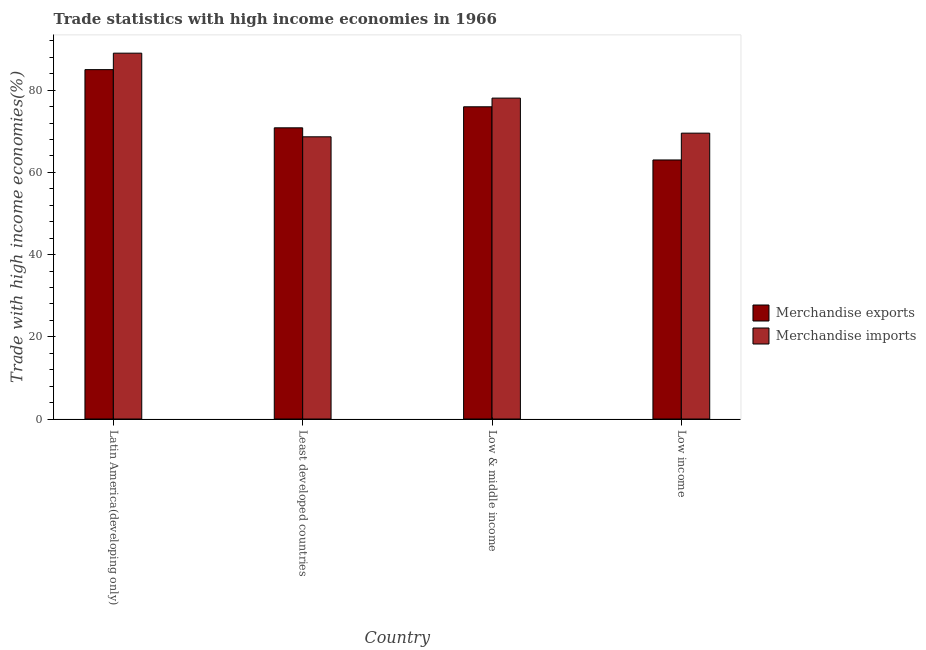How many groups of bars are there?
Your answer should be very brief. 4. What is the label of the 3rd group of bars from the left?
Make the answer very short. Low & middle income. What is the merchandise exports in Low income?
Make the answer very short. 63.03. Across all countries, what is the maximum merchandise exports?
Keep it short and to the point. 85.01. Across all countries, what is the minimum merchandise exports?
Your answer should be compact. 63.03. In which country was the merchandise imports maximum?
Make the answer very short. Latin America(developing only). What is the total merchandise imports in the graph?
Provide a succinct answer. 305.31. What is the difference between the merchandise imports in Latin America(developing only) and that in Low & middle income?
Provide a short and direct response. 10.93. What is the difference between the merchandise exports in Latin America(developing only) and the merchandise imports in Low & middle income?
Provide a short and direct response. 6.93. What is the average merchandise exports per country?
Your response must be concise. 73.71. What is the difference between the merchandise exports and merchandise imports in Least developed countries?
Provide a short and direct response. 2.19. What is the ratio of the merchandise exports in Least developed countries to that in Low & middle income?
Make the answer very short. 0.93. What is the difference between the highest and the second highest merchandise exports?
Offer a terse response. 9.04. What is the difference between the highest and the lowest merchandise imports?
Your answer should be compact. 20.35. In how many countries, is the merchandise imports greater than the average merchandise imports taken over all countries?
Your answer should be compact. 2. What does the 2nd bar from the left in Low & middle income represents?
Offer a very short reply. Merchandise imports. What is the difference between two consecutive major ticks on the Y-axis?
Provide a short and direct response. 20. Are the values on the major ticks of Y-axis written in scientific E-notation?
Your response must be concise. No. Does the graph contain grids?
Your answer should be compact. No. Where does the legend appear in the graph?
Provide a short and direct response. Center right. How are the legend labels stacked?
Keep it short and to the point. Vertical. What is the title of the graph?
Your response must be concise. Trade statistics with high income economies in 1966. Does "Overweight" appear as one of the legend labels in the graph?
Offer a very short reply. No. What is the label or title of the Y-axis?
Make the answer very short. Trade with high income economies(%). What is the Trade with high income economies(%) of Merchandise exports in Latin America(developing only)?
Keep it short and to the point. 85.01. What is the Trade with high income economies(%) in Merchandise imports in Latin America(developing only)?
Your response must be concise. 89.01. What is the Trade with high income economies(%) of Merchandise exports in Least developed countries?
Your answer should be compact. 70.85. What is the Trade with high income economies(%) of Merchandise imports in Least developed countries?
Ensure brevity in your answer.  68.66. What is the Trade with high income economies(%) of Merchandise exports in Low & middle income?
Provide a succinct answer. 75.97. What is the Trade with high income economies(%) of Merchandise imports in Low & middle income?
Your response must be concise. 78.08. What is the Trade with high income economies(%) of Merchandise exports in Low income?
Your answer should be very brief. 63.03. What is the Trade with high income economies(%) of Merchandise imports in Low income?
Provide a short and direct response. 69.55. Across all countries, what is the maximum Trade with high income economies(%) of Merchandise exports?
Your response must be concise. 85.01. Across all countries, what is the maximum Trade with high income economies(%) of Merchandise imports?
Provide a short and direct response. 89.01. Across all countries, what is the minimum Trade with high income economies(%) in Merchandise exports?
Your answer should be very brief. 63.03. Across all countries, what is the minimum Trade with high income economies(%) in Merchandise imports?
Ensure brevity in your answer.  68.66. What is the total Trade with high income economies(%) of Merchandise exports in the graph?
Offer a terse response. 294.85. What is the total Trade with high income economies(%) in Merchandise imports in the graph?
Give a very brief answer. 305.31. What is the difference between the Trade with high income economies(%) of Merchandise exports in Latin America(developing only) and that in Least developed countries?
Offer a terse response. 14.16. What is the difference between the Trade with high income economies(%) in Merchandise imports in Latin America(developing only) and that in Least developed countries?
Provide a succinct answer. 20.35. What is the difference between the Trade with high income economies(%) of Merchandise exports in Latin America(developing only) and that in Low & middle income?
Your response must be concise. 9.04. What is the difference between the Trade with high income economies(%) of Merchandise imports in Latin America(developing only) and that in Low & middle income?
Keep it short and to the point. 10.93. What is the difference between the Trade with high income economies(%) in Merchandise exports in Latin America(developing only) and that in Low income?
Offer a terse response. 21.98. What is the difference between the Trade with high income economies(%) of Merchandise imports in Latin America(developing only) and that in Low income?
Your answer should be compact. 19.46. What is the difference between the Trade with high income economies(%) of Merchandise exports in Least developed countries and that in Low & middle income?
Give a very brief answer. -5.12. What is the difference between the Trade with high income economies(%) of Merchandise imports in Least developed countries and that in Low & middle income?
Your answer should be compact. -9.42. What is the difference between the Trade with high income economies(%) of Merchandise exports in Least developed countries and that in Low income?
Your answer should be compact. 7.82. What is the difference between the Trade with high income economies(%) in Merchandise imports in Least developed countries and that in Low income?
Your answer should be compact. -0.89. What is the difference between the Trade with high income economies(%) of Merchandise exports in Low & middle income and that in Low income?
Offer a very short reply. 12.94. What is the difference between the Trade with high income economies(%) of Merchandise imports in Low & middle income and that in Low income?
Give a very brief answer. 8.53. What is the difference between the Trade with high income economies(%) of Merchandise exports in Latin America(developing only) and the Trade with high income economies(%) of Merchandise imports in Least developed countries?
Ensure brevity in your answer.  16.34. What is the difference between the Trade with high income economies(%) of Merchandise exports in Latin America(developing only) and the Trade with high income economies(%) of Merchandise imports in Low & middle income?
Ensure brevity in your answer.  6.93. What is the difference between the Trade with high income economies(%) of Merchandise exports in Latin America(developing only) and the Trade with high income economies(%) of Merchandise imports in Low income?
Provide a succinct answer. 15.45. What is the difference between the Trade with high income economies(%) in Merchandise exports in Least developed countries and the Trade with high income economies(%) in Merchandise imports in Low & middle income?
Give a very brief answer. -7.23. What is the difference between the Trade with high income economies(%) in Merchandise exports in Least developed countries and the Trade with high income economies(%) in Merchandise imports in Low income?
Keep it short and to the point. 1.3. What is the difference between the Trade with high income economies(%) in Merchandise exports in Low & middle income and the Trade with high income economies(%) in Merchandise imports in Low income?
Keep it short and to the point. 6.41. What is the average Trade with high income economies(%) of Merchandise exports per country?
Provide a succinct answer. 73.71. What is the average Trade with high income economies(%) in Merchandise imports per country?
Offer a very short reply. 76.33. What is the difference between the Trade with high income economies(%) of Merchandise exports and Trade with high income economies(%) of Merchandise imports in Latin America(developing only)?
Your response must be concise. -4. What is the difference between the Trade with high income economies(%) in Merchandise exports and Trade with high income economies(%) in Merchandise imports in Least developed countries?
Keep it short and to the point. 2.19. What is the difference between the Trade with high income economies(%) in Merchandise exports and Trade with high income economies(%) in Merchandise imports in Low & middle income?
Provide a short and direct response. -2.11. What is the difference between the Trade with high income economies(%) in Merchandise exports and Trade with high income economies(%) in Merchandise imports in Low income?
Your answer should be compact. -6.53. What is the ratio of the Trade with high income economies(%) in Merchandise exports in Latin America(developing only) to that in Least developed countries?
Your answer should be very brief. 1.2. What is the ratio of the Trade with high income economies(%) in Merchandise imports in Latin America(developing only) to that in Least developed countries?
Keep it short and to the point. 1.3. What is the ratio of the Trade with high income economies(%) in Merchandise exports in Latin America(developing only) to that in Low & middle income?
Offer a very short reply. 1.12. What is the ratio of the Trade with high income economies(%) of Merchandise imports in Latin America(developing only) to that in Low & middle income?
Give a very brief answer. 1.14. What is the ratio of the Trade with high income economies(%) in Merchandise exports in Latin America(developing only) to that in Low income?
Make the answer very short. 1.35. What is the ratio of the Trade with high income economies(%) in Merchandise imports in Latin America(developing only) to that in Low income?
Ensure brevity in your answer.  1.28. What is the ratio of the Trade with high income economies(%) in Merchandise exports in Least developed countries to that in Low & middle income?
Your answer should be compact. 0.93. What is the ratio of the Trade with high income economies(%) in Merchandise imports in Least developed countries to that in Low & middle income?
Your response must be concise. 0.88. What is the ratio of the Trade with high income economies(%) in Merchandise exports in Least developed countries to that in Low income?
Give a very brief answer. 1.12. What is the ratio of the Trade with high income economies(%) of Merchandise imports in Least developed countries to that in Low income?
Provide a short and direct response. 0.99. What is the ratio of the Trade with high income economies(%) in Merchandise exports in Low & middle income to that in Low income?
Ensure brevity in your answer.  1.21. What is the ratio of the Trade with high income economies(%) in Merchandise imports in Low & middle income to that in Low income?
Ensure brevity in your answer.  1.12. What is the difference between the highest and the second highest Trade with high income economies(%) of Merchandise exports?
Provide a succinct answer. 9.04. What is the difference between the highest and the second highest Trade with high income economies(%) of Merchandise imports?
Offer a very short reply. 10.93. What is the difference between the highest and the lowest Trade with high income economies(%) in Merchandise exports?
Make the answer very short. 21.98. What is the difference between the highest and the lowest Trade with high income economies(%) of Merchandise imports?
Offer a terse response. 20.35. 